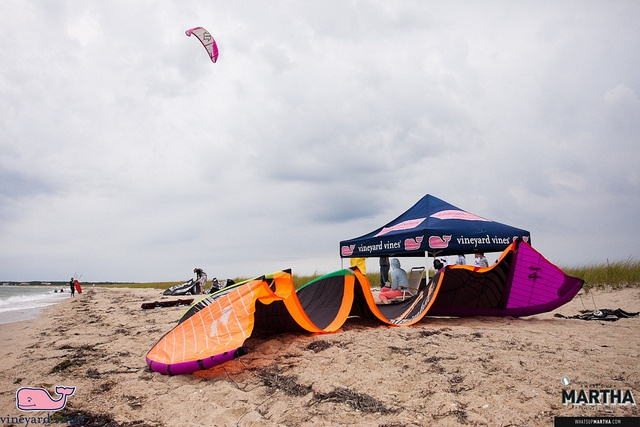Describe the objects in this image and their specific colors. I can see kite in lightgray, black, orange, tan, and red tones, umbrella in lightgray, black, navy, darkblue, and blue tones, people in lightgray, salmon, darkgray, and gray tones, kite in lightgray, darkgray, pink, and brown tones, and kite in lightgray, black, gray, and darkgray tones in this image. 